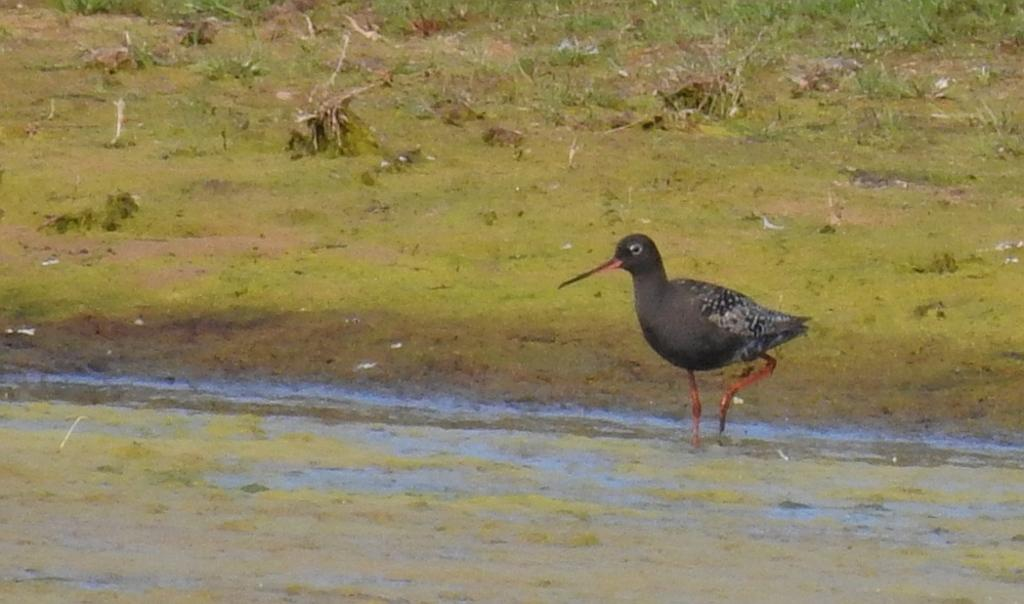What type of animal is present in the image? There is a bird in the image. What is located at the bottom of the image? There is water at the bottom of the image. What can be seen in the background of the image? There is grass in the background of the image. Can you see a wall in the image? No, there is no wall present in the image. Are there any clams visible in the water? No, there are no clams visible in the image. 